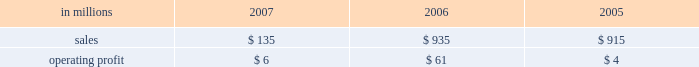Expenses decreased to $ 23 million from $ 115 million in 2006 and $ 146 million in 2005 , reflecting the reduced level of operations .
Operating profits for the real estate division , which principally sells higher-and-better-use properties , were $ 32 million , $ 124 million and $ 198 million in 2007 , 2006 and 2005 , respectively .
Looking forward to 2008 , operating profits are expected to decline significantly , reflecting the reduced level of forestland holdings .
Operating earn- ings will primarily reflect the periodic sales of remaining acreage , and can be expected to vary from quarter to quarter depending on the timing of sale transactions .
Specialty businesses and other the specialty businesses and other segment princi- pally includes the operating results of the arizona chemical business as well as certain smaller busi- nesses .
The arizona chemical business was sold in february 2007 .
Thus , operating results in 2007 reflect only two months of activity .
Specialty businesses and other in millions 2007 2006 2005 .
Liquidity and capital resources overview a major factor in international paper 2019s liquidity and capital resource planning is its generation of operat- ing cash flow , which is highly sensitive to changes in the pricing and demand for our major products .
While changes in key cash operating costs , such as energy , raw material and transportation costs , do have an effect on operating cash generation , we believe that our strong focus on cost controls has improved our cash flow generation over an operat- ing cycle .
As part of our continuing focus on improving our return on investment , we have focused our capital spending on improving our key paper and packaging businesses both globally and in north america .
Financing activities in 2007 continued the focus on the transformation plan objectives of returning value to shareholders through additional repurchases of common stock and strengthening the balance sheet through further reductions of management believes it is important for interna- tional paper to maintain an investment-grade credit rating to facilitate access to capital markets on favorable terms .
At december 31 , 2007 , the com- pany held long-term credit ratings of bbb ( stable outlook ) and baa3 ( stable outlook ) by standard & poor 2019s ( s&p ) and moody 2019s investor services ( moody 2019s ) , respectively .
Cash provided by operations cash provided by continuing operations totaled $ 1.9 billion , compared with $ 1.0 billion for 2006 and $ 1.2 billion for 2005 .
The 2006 amount is net of a $ 1.0 bil- lion voluntary cash pension plan contribution made in the fourth quarter of 2006 .
The major components of cash provided by continuing operations are earn- ings from continuing operations adjusted for non-cash income and expense items and changes in working capital .
Earnings from continuing oper- ations , adjusted for non-cash items and excluding the pension contribution in 2006 , increased by $ 123 million in 2007 versus 2006 .
This compared with an increase of $ 584 million for 2006 over 2005 .
International paper 2019s investments in accounts receiv- able and inventory less accounts payable and accrued liabilities , totaled $ 1.7 billion at december 31 , 2007 .
Cash used for these working capital components increased by $ 539 million in 2007 , compared with a $ 354 million increase in 2006 and a $ 558 million increase in 2005 .
Investment activities investment activities in 2007 included the receipt of $ 1.7 billion of additional cash proceeds from divest- itures , and the use of $ 239 million for acquisitions and $ 578 million for an investment in a 50% ( 50 % ) equity interest in ilim holding s.a .
In russia .
Capital spending from continuing operations was $ 1.3 billion in 2007 , or 119% ( 119 % ) of depreciation and amortization , comparable to $ 1.0 billion , or 87% ( 87 % ) of depreciation and amortization in 2006 , and $ 992 mil- lion , or 78% ( 78 % ) of depreciation and amortization in 2005 .
The increase in 2007 reflects spending for the con- version of the pensacola paper machine to the pro- duction of linerboard , a fluff pulp project at our riegelwood mill , and a specialty pulp production project at our svetogorsk mill in russia , all of which were part of the company 2019s transformation plan. .
What was the specialty business profit margin in 2006? 
Computations: (61 / 935)
Answer: 0.06524. 